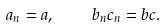Convert formula to latex. <formula><loc_0><loc_0><loc_500><loc_500>a _ { n } = a , \quad b _ { n } c _ { n } = b c .</formula> 